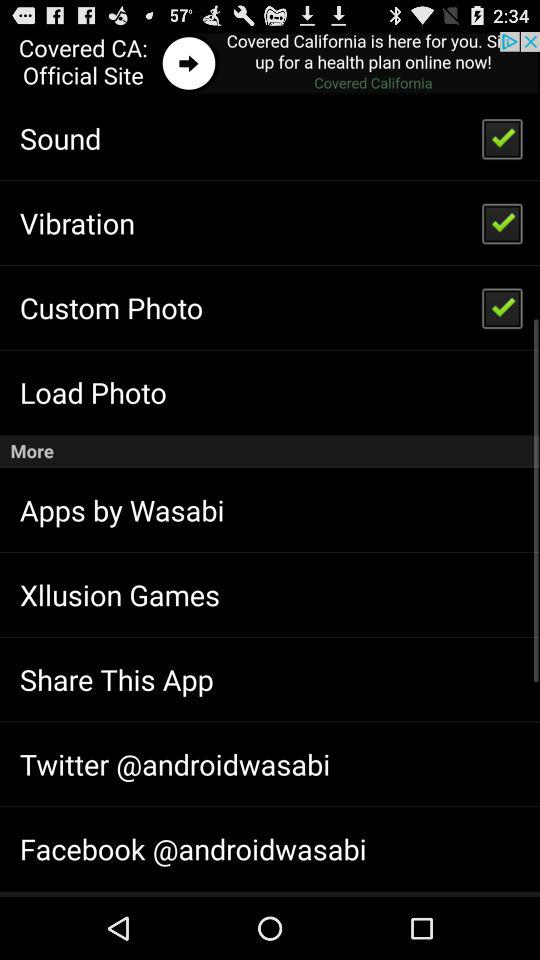How many photos have been loaded?
When the provided information is insufficient, respond with <no answer>. <no answer> 